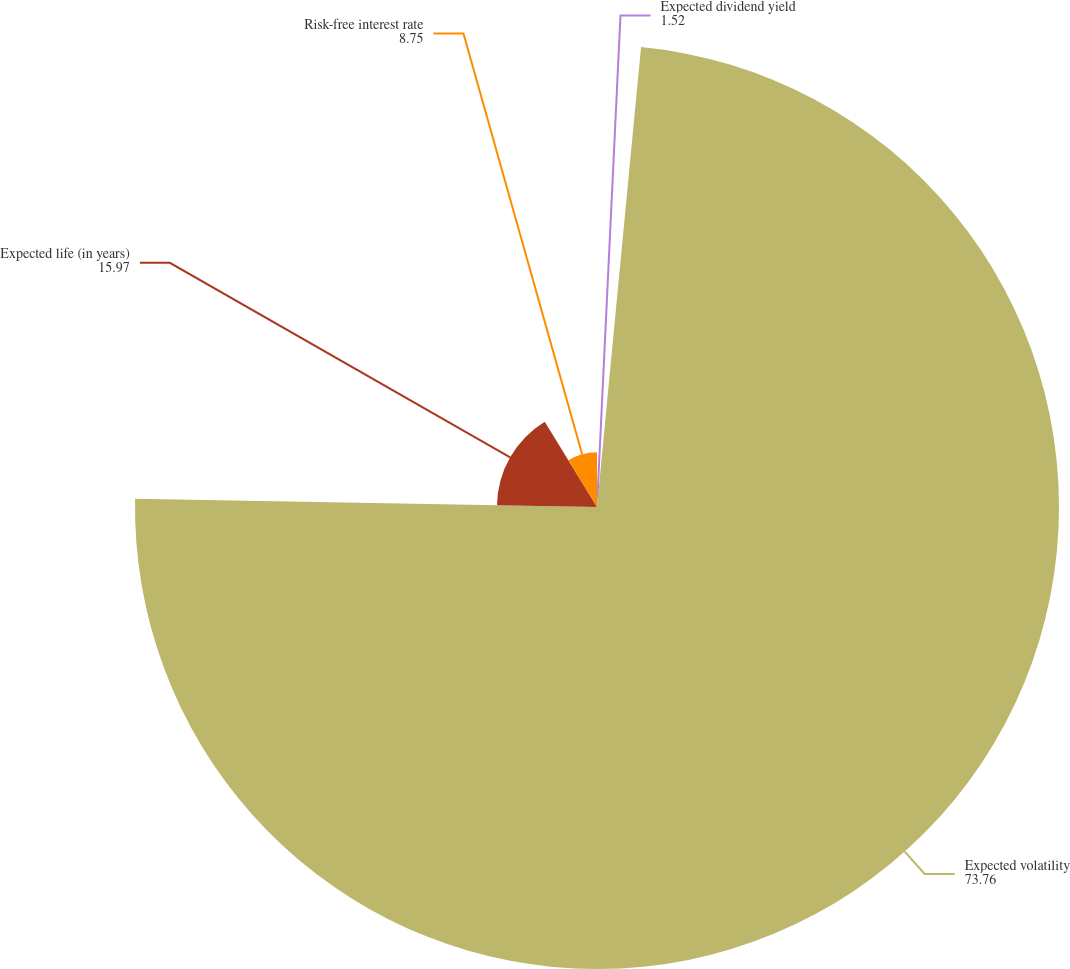Convert chart. <chart><loc_0><loc_0><loc_500><loc_500><pie_chart><fcel>Expected dividend yield<fcel>Expected volatility<fcel>Expected life (in years)<fcel>Risk-free interest rate<nl><fcel>1.52%<fcel>73.76%<fcel>15.97%<fcel>8.75%<nl></chart> 